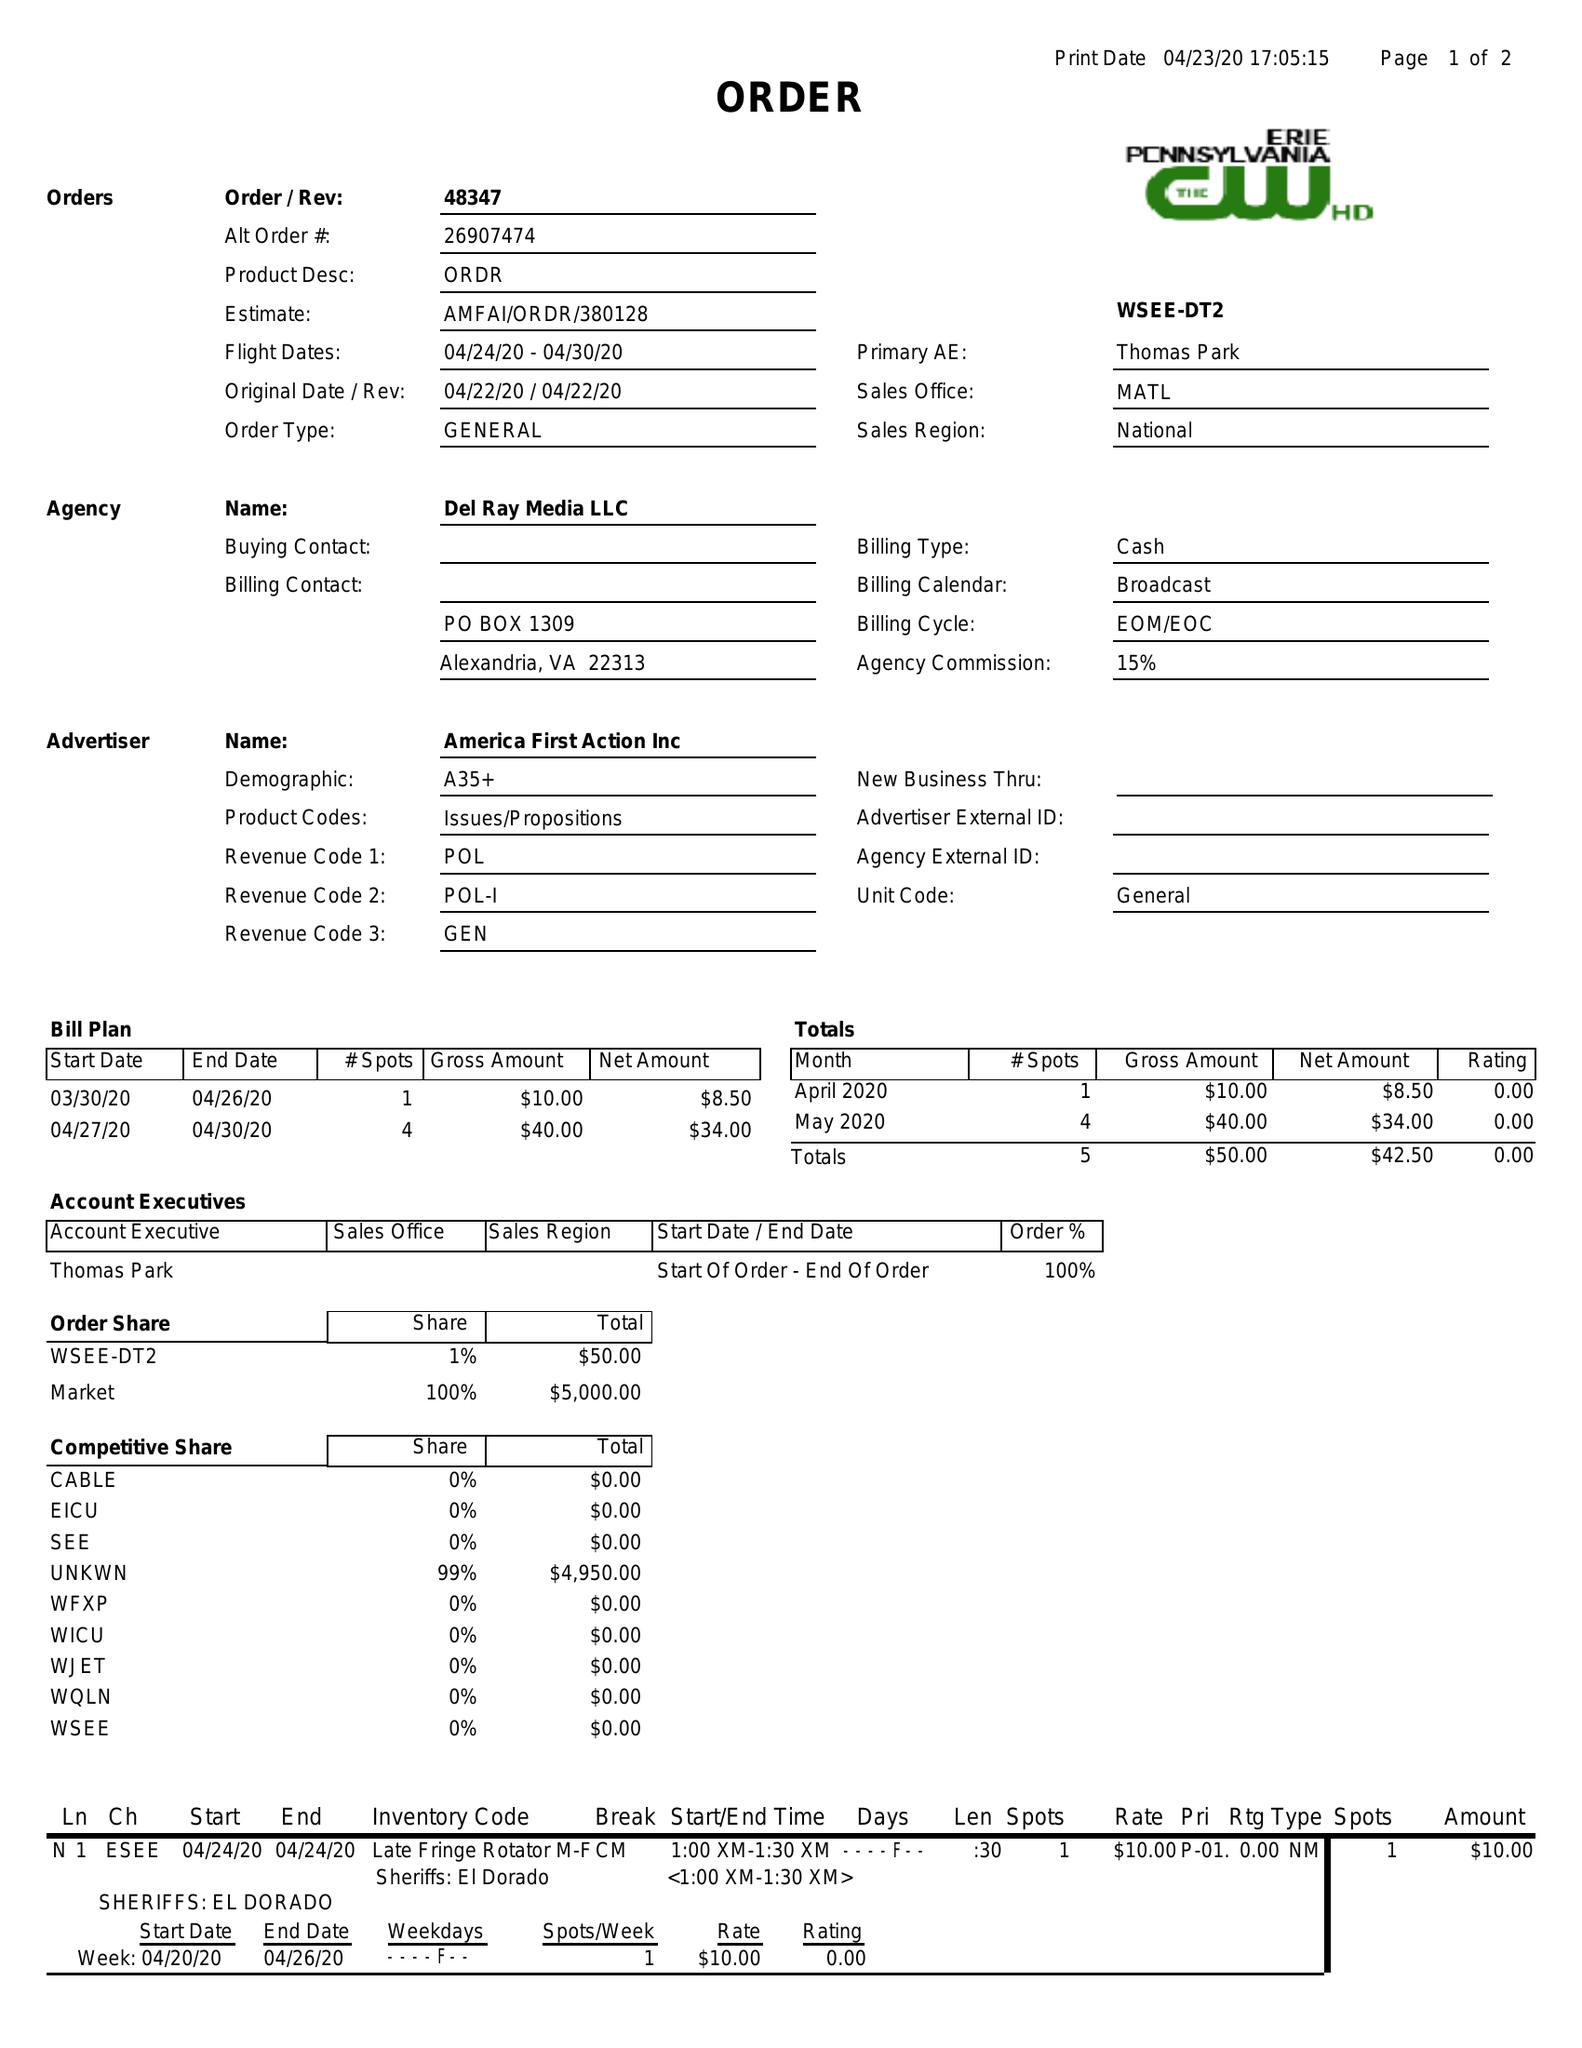What is the value for the contract_num?
Answer the question using a single word or phrase. 48347 